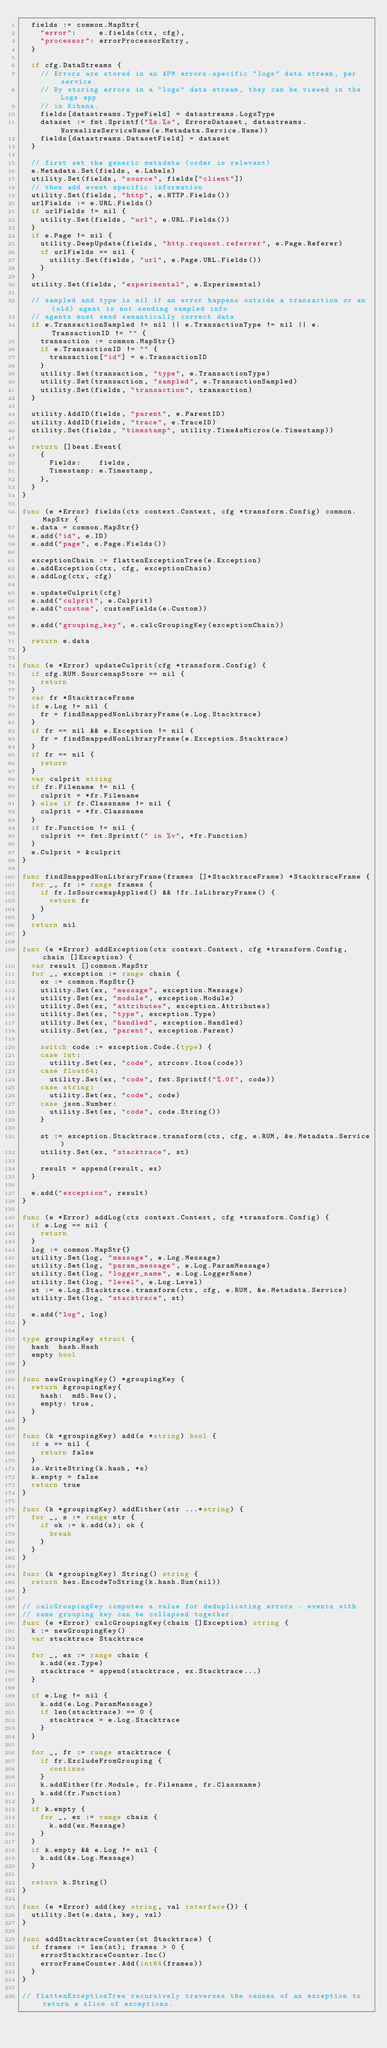<code> <loc_0><loc_0><loc_500><loc_500><_Go_>	fields := common.MapStr{
		"error":     e.fields(ctx, cfg),
		"processor": errorProcessorEntry,
	}

	if cfg.DataStreams {
		// Errors are stored in an APM errors-specific "logs" data stream, per service.
		// By storing errors in a "logs" data stream, they can be viewed in the Logs app
		// in Kibana.
		fields[datastreams.TypeField] = datastreams.LogsType
		dataset := fmt.Sprintf("%s.%s", ErrorsDataset, datastreams.NormalizeServiceName(e.Metadata.Service.Name))
		fields[datastreams.DatasetField] = dataset
	}

	// first set the generic metadata (order is relevant)
	e.Metadata.Set(fields, e.Labels)
	utility.Set(fields, "source", fields["client"])
	// then add event specific information
	utility.Set(fields, "http", e.HTTP.Fields())
	urlFields := e.URL.Fields()
	if urlFields != nil {
		utility.Set(fields, "url", e.URL.Fields())
	}
	if e.Page != nil {
		utility.DeepUpdate(fields, "http.request.referrer", e.Page.Referer)
		if urlFields == nil {
			utility.Set(fields, "url", e.Page.URL.Fields())
		}
	}
	utility.Set(fields, "experimental", e.Experimental)

	// sampled and type is nil if an error happens outside a transaction or an (old) agent is not sending sampled info
	// agents must send semantically correct data
	if e.TransactionSampled != nil || e.TransactionType != nil || e.TransactionID != "" {
		transaction := common.MapStr{}
		if e.TransactionID != "" {
			transaction["id"] = e.TransactionID
		}
		utility.Set(transaction, "type", e.TransactionType)
		utility.Set(transaction, "sampled", e.TransactionSampled)
		utility.Set(fields, "transaction", transaction)
	}

	utility.AddID(fields, "parent", e.ParentID)
	utility.AddID(fields, "trace", e.TraceID)
	utility.Set(fields, "timestamp", utility.TimeAsMicros(e.Timestamp))

	return []beat.Event{
		{
			Fields:    fields,
			Timestamp: e.Timestamp,
		},
	}
}

func (e *Error) fields(ctx context.Context, cfg *transform.Config) common.MapStr {
	e.data = common.MapStr{}
	e.add("id", e.ID)
	e.add("page", e.Page.Fields())

	exceptionChain := flattenExceptionTree(e.Exception)
	e.addException(ctx, cfg, exceptionChain)
	e.addLog(ctx, cfg)

	e.updateCulprit(cfg)
	e.add("culprit", e.Culprit)
	e.add("custom", customFields(e.Custom))

	e.add("grouping_key", e.calcGroupingKey(exceptionChain))

	return e.data
}

func (e *Error) updateCulprit(cfg *transform.Config) {
	if cfg.RUM.SourcemapStore == nil {
		return
	}
	var fr *StacktraceFrame
	if e.Log != nil {
		fr = findSmappedNonLibraryFrame(e.Log.Stacktrace)
	}
	if fr == nil && e.Exception != nil {
		fr = findSmappedNonLibraryFrame(e.Exception.Stacktrace)
	}
	if fr == nil {
		return
	}
	var culprit string
	if fr.Filename != nil {
		culprit = *fr.Filename
	} else if fr.Classname != nil {
		culprit = *fr.Classname
	}
	if fr.Function != nil {
		culprit += fmt.Sprintf(" in %v", *fr.Function)
	}
	e.Culprit = &culprit
}

func findSmappedNonLibraryFrame(frames []*StacktraceFrame) *StacktraceFrame {
	for _, fr := range frames {
		if fr.IsSourcemapApplied() && !fr.IsLibraryFrame() {
			return fr
		}
	}
	return nil
}

func (e *Error) addException(ctx context.Context, cfg *transform.Config, chain []Exception) {
	var result []common.MapStr
	for _, exception := range chain {
		ex := common.MapStr{}
		utility.Set(ex, "message", exception.Message)
		utility.Set(ex, "module", exception.Module)
		utility.Set(ex, "attributes", exception.Attributes)
		utility.Set(ex, "type", exception.Type)
		utility.Set(ex, "handled", exception.Handled)
		utility.Set(ex, "parent", exception.Parent)

		switch code := exception.Code.(type) {
		case int:
			utility.Set(ex, "code", strconv.Itoa(code))
		case float64:
			utility.Set(ex, "code", fmt.Sprintf("%.0f", code))
		case string:
			utility.Set(ex, "code", code)
		case json.Number:
			utility.Set(ex, "code", code.String())
		}

		st := exception.Stacktrace.transform(ctx, cfg, e.RUM, &e.Metadata.Service)
		utility.Set(ex, "stacktrace", st)

		result = append(result, ex)
	}

	e.add("exception", result)
}

func (e *Error) addLog(ctx context.Context, cfg *transform.Config) {
	if e.Log == nil {
		return
	}
	log := common.MapStr{}
	utility.Set(log, "message", e.Log.Message)
	utility.Set(log, "param_message", e.Log.ParamMessage)
	utility.Set(log, "logger_name", e.Log.LoggerName)
	utility.Set(log, "level", e.Log.Level)
	st := e.Log.Stacktrace.transform(ctx, cfg, e.RUM, &e.Metadata.Service)
	utility.Set(log, "stacktrace", st)

	e.add("log", log)
}

type groupingKey struct {
	hash  hash.Hash
	empty bool
}

func newGroupingKey() *groupingKey {
	return &groupingKey{
		hash:  md5.New(),
		empty: true,
	}
}

func (k *groupingKey) add(s *string) bool {
	if s == nil {
		return false
	}
	io.WriteString(k.hash, *s)
	k.empty = false
	return true
}

func (k *groupingKey) addEither(str ...*string) {
	for _, s := range str {
		if ok := k.add(s); ok {
			break
		}
	}
}

func (k *groupingKey) String() string {
	return hex.EncodeToString(k.hash.Sum(nil))
}

// calcGroupingKey computes a value for deduplicating errors - events with
// same grouping key can be collapsed together.
func (e *Error) calcGroupingKey(chain []Exception) string {
	k := newGroupingKey()
	var stacktrace Stacktrace

	for _, ex := range chain {
		k.add(ex.Type)
		stacktrace = append(stacktrace, ex.Stacktrace...)
	}

	if e.Log != nil {
		k.add(e.Log.ParamMessage)
		if len(stacktrace) == 0 {
			stacktrace = e.Log.Stacktrace
		}
	}

	for _, fr := range stacktrace {
		if fr.ExcludeFromGrouping {
			continue
		}
		k.addEither(fr.Module, fr.Filename, fr.Classname)
		k.add(fr.Function)
	}
	if k.empty {
		for _, ex := range chain {
			k.add(ex.Message)
		}
	}
	if k.empty && e.Log != nil {
		k.add(&e.Log.Message)
	}

	return k.String()
}

func (e *Error) add(key string, val interface{}) {
	utility.Set(e.data, key, val)
}

func addStacktraceCounter(st Stacktrace) {
	if frames := len(st); frames > 0 {
		errorStacktraceCounter.Inc()
		errorFrameCounter.Add(int64(frames))
	}
}

// flattenExceptionTree recursively traverses the causes of an exception to return a slice of exceptions.</code> 